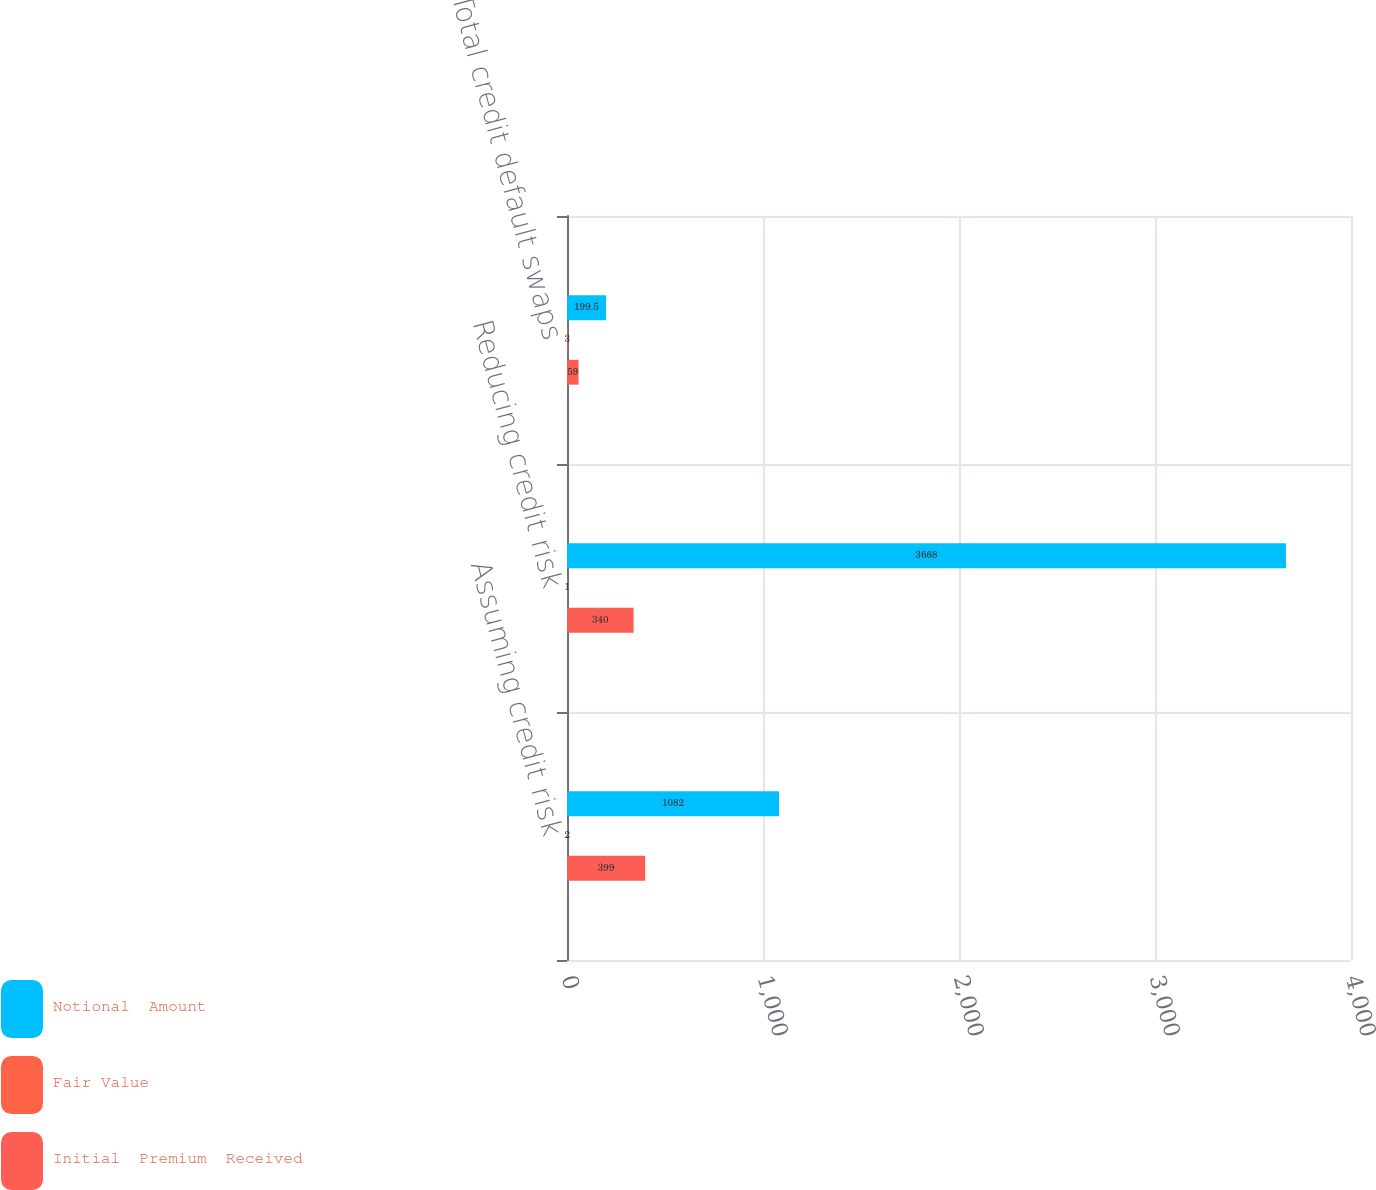Convert chart. <chart><loc_0><loc_0><loc_500><loc_500><stacked_bar_chart><ecel><fcel>Assuming credit risk<fcel>Reducing credit risk<fcel>Total credit default swaps<nl><fcel>Notional  Amount<fcel>1082<fcel>3668<fcel>199.5<nl><fcel>Fair Value<fcel>2<fcel>1<fcel>3<nl><fcel>Initial  Premium  Received<fcel>399<fcel>340<fcel>59<nl></chart> 